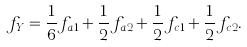Convert formula to latex. <formula><loc_0><loc_0><loc_500><loc_500>f _ { Y } = \frac { 1 } { 6 } f _ { a 1 } + \frac { 1 } { 2 } f _ { a 2 } + \frac { 1 } { 2 } f _ { c 1 } + \frac { 1 } { 2 } f _ { c 2 } .</formula> 